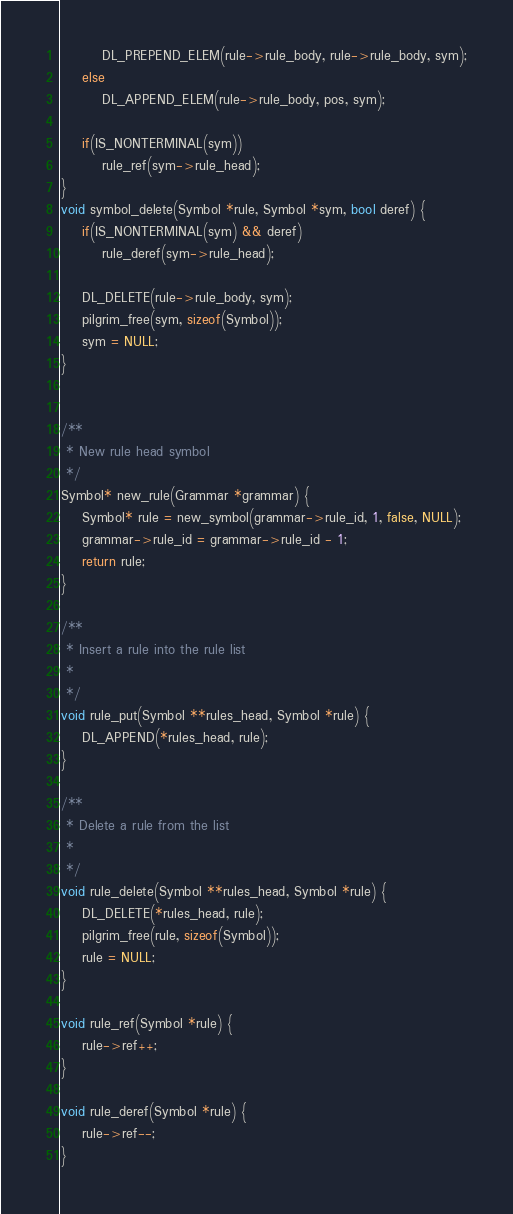<code> <loc_0><loc_0><loc_500><loc_500><_C_>        DL_PREPEND_ELEM(rule->rule_body, rule->rule_body, sym);
    else
        DL_APPEND_ELEM(rule->rule_body, pos, sym);

    if(IS_NONTERMINAL(sym))
        rule_ref(sym->rule_head);
}
void symbol_delete(Symbol *rule, Symbol *sym, bool deref) {
    if(IS_NONTERMINAL(sym) && deref)
        rule_deref(sym->rule_head);

    DL_DELETE(rule->rule_body, sym);
    pilgrim_free(sym, sizeof(Symbol));
    sym = NULL;
}


/**
 * New rule head symbol
 */
Symbol* new_rule(Grammar *grammar) {
    Symbol* rule = new_symbol(grammar->rule_id, 1, false, NULL);
    grammar->rule_id = grammar->rule_id - 1;
    return rule;
}

/**
 * Insert a rule into the rule list
 *
 */
void rule_put(Symbol **rules_head, Symbol *rule) {
    DL_APPEND(*rules_head, rule);
}

/**
 * Delete a rule from the list
 *
 */
void rule_delete(Symbol **rules_head, Symbol *rule) {
    DL_DELETE(*rules_head, rule);
    pilgrim_free(rule, sizeof(Symbol));
    rule = NULL;
}

void rule_ref(Symbol *rule) {
    rule->ref++;
}

void rule_deref(Symbol *rule) {
    rule->ref--;
}
</code> 